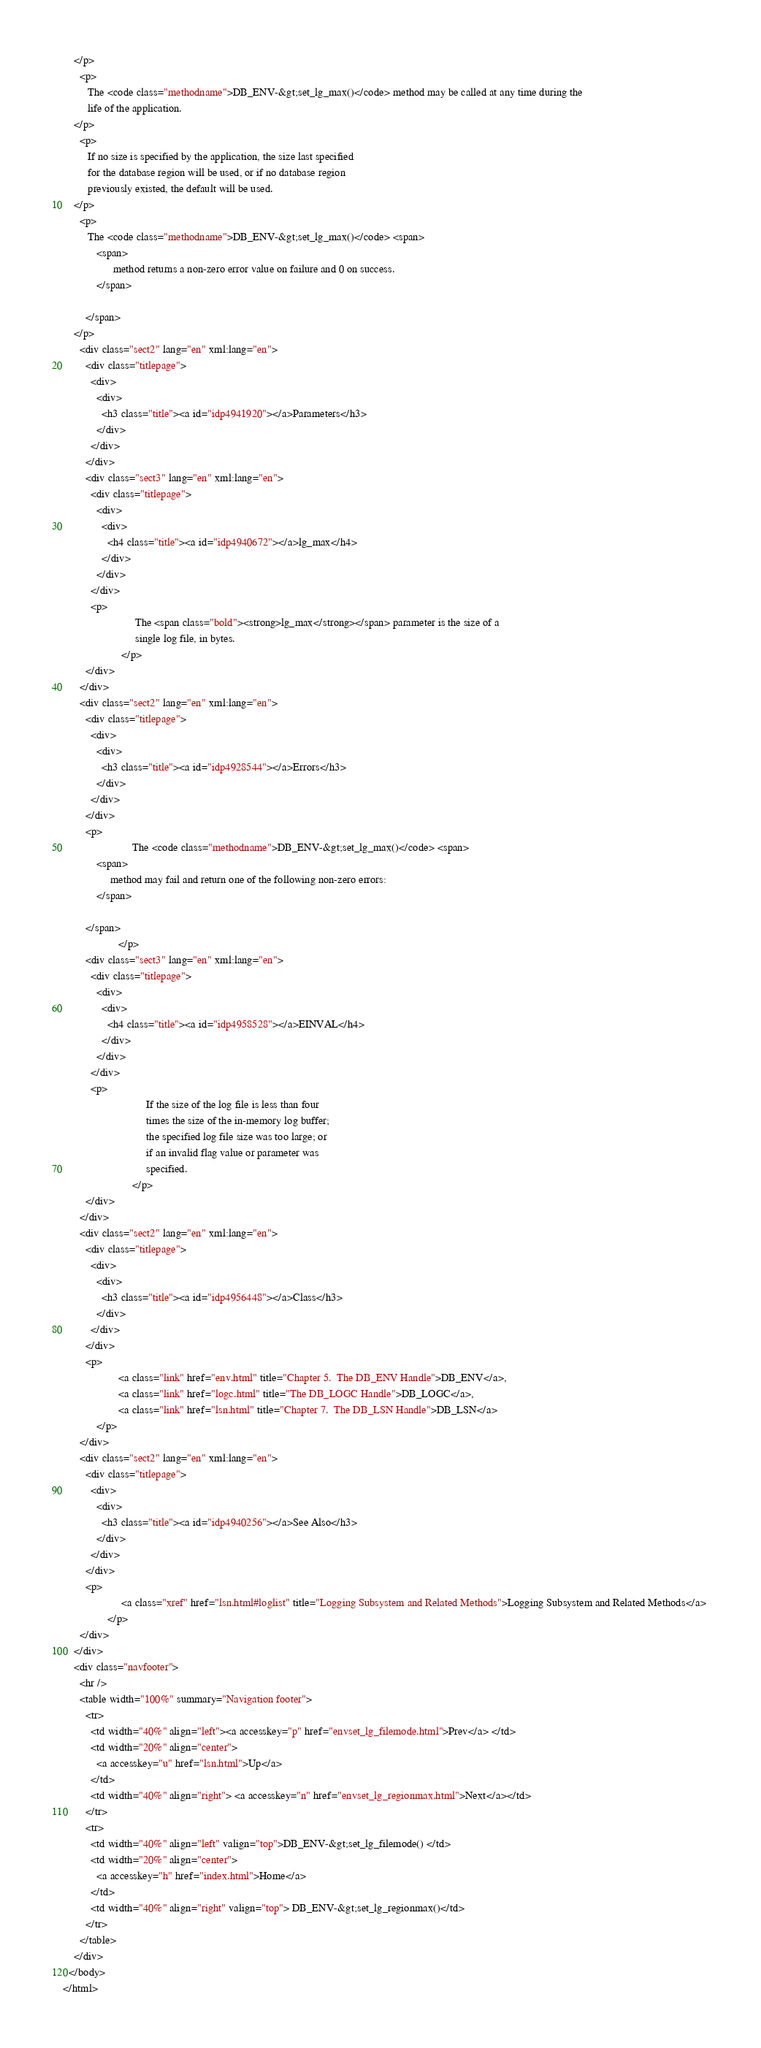<code> <loc_0><loc_0><loc_500><loc_500><_HTML_>    </p>
      <p>
         The <code class="methodname">DB_ENV-&gt;set_lg_max()</code> method may be called at any time during the
         life of the application.
    </p>
      <p>
         If no size is specified by the application, the size last specified
         for the database region will be used, or if no database region
         previously existed, the default will be used.
    </p>
      <p>
         The <code class="methodname">DB_ENV-&gt;set_lg_max()</code> <span>
            <span>
                  method returns a non-zero error value on failure and 0 on success.
            </span>
            
        </span>
    </p>
      <div class="sect2" lang="en" xml:lang="en">
        <div class="titlepage">
          <div>
            <div>
              <h3 class="title"><a id="idp4941920"></a>Parameters</h3>
            </div>
          </div>
        </div>
        <div class="sect3" lang="en" xml:lang="en">
          <div class="titlepage">
            <div>
              <div>
                <h4 class="title"><a id="idp4940672"></a>lg_max</h4>
              </div>
            </div>
          </div>
          <p>
                          The <span class="bold"><strong>lg_max</strong></span> parameter is the size of a
                          single log file, in bytes.
                     </p>
        </div>
      </div>
      <div class="sect2" lang="en" xml:lang="en">
        <div class="titlepage">
          <div>
            <div>
              <h3 class="title"><a id="idp4928544"></a>Errors</h3>
            </div>
          </div>
        </div>
        <p>
                         The <code class="methodname">DB_ENV-&gt;set_lg_max()</code> <span>
            <span>
                 method may fail and return one of the following non-zero errors:
            </span>
            
        </span>
                    </p>
        <div class="sect3" lang="en" xml:lang="en">
          <div class="titlepage">
            <div>
              <div>
                <h4 class="title"><a id="idp4958528"></a>EINVAL</h4>
              </div>
            </div>
          </div>
          <p>
                              If the size of the log file is less than four
                              times the size of the in-memory log buffer;
                              the specified log file size was too large; or
                              if an invalid flag value or parameter was
                              specified.
                         </p>
        </div>
      </div>
      <div class="sect2" lang="en" xml:lang="en">
        <div class="titlepage">
          <div>
            <div>
              <h3 class="title"><a id="idp4956448"></a>Class</h3>
            </div>
          </div>
        </div>
        <p>
                    <a class="link" href="env.html" title="Chapter 5.  The DB_ENV Handle">DB_ENV</a>, 
                    <a class="link" href="logc.html" title="The DB_LOGC Handle">DB_LOGC</a>, 
                    <a class="link" href="lsn.html" title="Chapter 7.  The DB_LSN Handle">DB_LSN</a> 
            </p>
      </div>
      <div class="sect2" lang="en" xml:lang="en">
        <div class="titlepage">
          <div>
            <div>
              <h3 class="title"><a id="idp4940256"></a>See Also</h3>
            </div>
          </div>
        </div>
        <p>
                     <a class="xref" href="lsn.html#loglist" title="Logging Subsystem and Related Methods">Logging Subsystem and Related Methods</a> 
                </p>
      </div>
    </div>
    <div class="navfooter">
      <hr />
      <table width="100%" summary="Navigation footer">
        <tr>
          <td width="40%" align="left"><a accesskey="p" href="envset_lg_filemode.html">Prev</a> </td>
          <td width="20%" align="center">
            <a accesskey="u" href="lsn.html">Up</a>
          </td>
          <td width="40%" align="right"> <a accesskey="n" href="envset_lg_regionmax.html">Next</a></td>
        </tr>
        <tr>
          <td width="40%" align="left" valign="top">DB_ENV-&gt;set_lg_filemode() </td>
          <td width="20%" align="center">
            <a accesskey="h" href="index.html">Home</a>
          </td>
          <td width="40%" align="right" valign="top"> DB_ENV-&gt;set_lg_regionmax()</td>
        </tr>
      </table>
    </div>
  </body>
</html>
</code> 